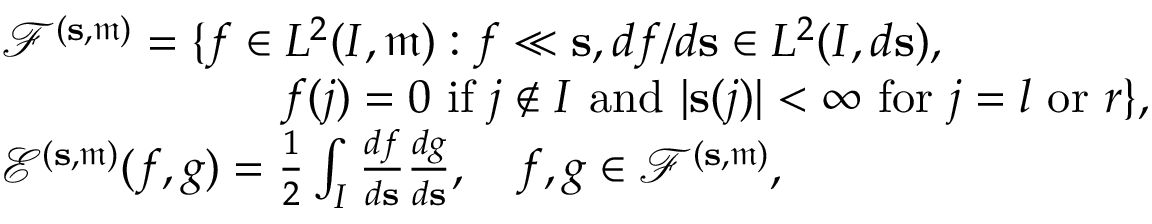Convert formula to latex. <formula><loc_0><loc_0><loc_500><loc_500>\begin{array} { r l } & { { \ m a t h s c r F } ^ { ( s , \mathfrak { m } ) } = \{ f \in L ^ { 2 } ( I , \mathfrak { m } ) \colon f \ll s , d f / d s \in L ^ { 2 } ( I , d s ) , } \\ & { \quad f ( j ) = 0 i f j \notin I a n d | s ( j ) | < \infty f o r j = l o r r \} , } \\ & { { \ m a t h s c r E } ^ { ( s , \mathfrak { m } ) } ( f , g ) = \frac { 1 } { 2 } \int _ { I } \frac { d f } { d s } \frac { d g } { d s } , \quad f , g \in { \ m a t h s c r F } ^ { ( s , \mathfrak { m } ) } , } \end{array}</formula> 